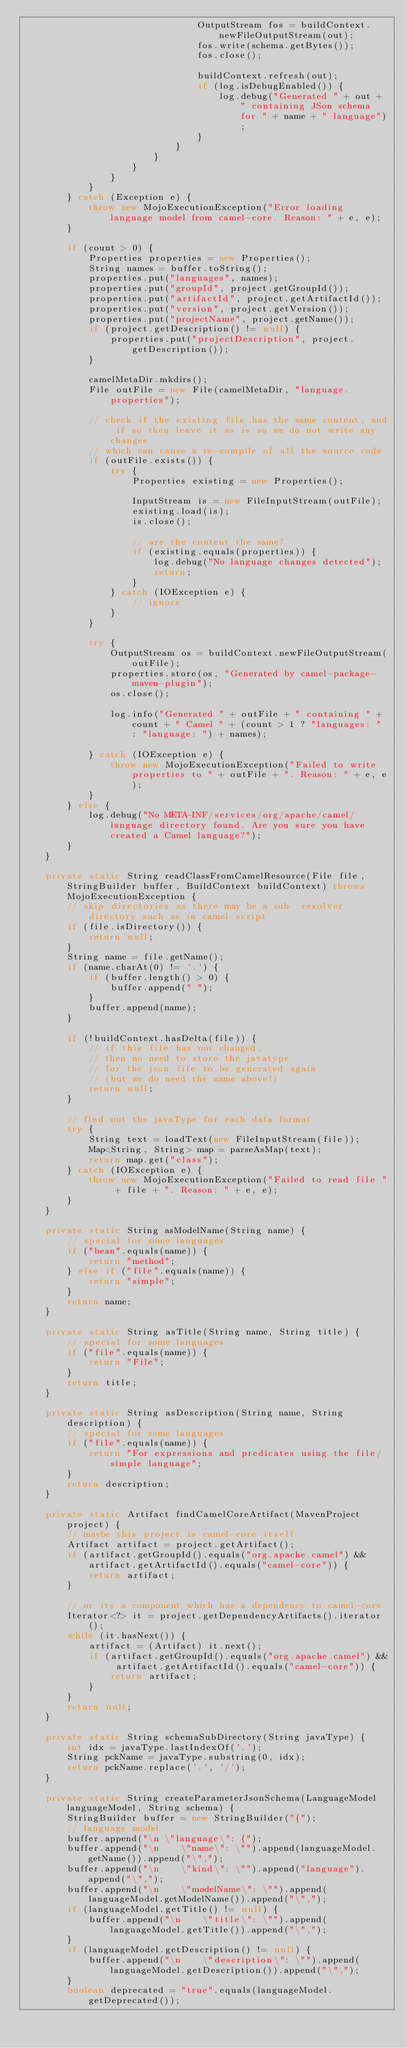Convert code to text. <code><loc_0><loc_0><loc_500><loc_500><_Java_>                                OutputStream fos = buildContext.newFileOutputStream(out);
                                fos.write(schema.getBytes());
                                fos.close();

                                buildContext.refresh(out);
                                if (log.isDebugEnabled()) {
                                    log.debug("Generated " + out + " containing JSon schema for " + name + " language");
                                }
                            }
                        }
                    }
                }
            }
        } catch (Exception e) {
            throw new MojoExecutionException("Error loading language model from camel-core. Reason: " + e, e);
        }

        if (count > 0) {
            Properties properties = new Properties();
            String names = buffer.toString();
            properties.put("languages", names);
            properties.put("groupId", project.getGroupId());
            properties.put("artifactId", project.getArtifactId());
            properties.put("version", project.getVersion());
            properties.put("projectName", project.getName());
            if (project.getDescription() != null) {
                properties.put("projectDescription", project.getDescription());
            }

            camelMetaDir.mkdirs();
            File outFile = new File(camelMetaDir, "language.properties");

            // check if the existing file has the same content, and if so then leave it as is so we do not write any changes
            // which can cause a re-compile of all the source code
            if (outFile.exists()) {
                try {
                    Properties existing = new Properties();

                    InputStream is = new FileInputStream(outFile);
                    existing.load(is);
                    is.close();

                    // are the content the same?
                    if (existing.equals(properties)) {
                        log.debug("No language changes detected");
                        return;
                    }
                } catch (IOException e) {
                    // ignore
                }
            }

            try {
                OutputStream os = buildContext.newFileOutputStream(outFile);
                properties.store(os, "Generated by camel-package-maven-plugin");
                os.close();

                log.info("Generated " + outFile + " containing " + count + " Camel " + (count > 1 ? "languages: " : "language: ") + names);

            } catch (IOException e) {
                throw new MojoExecutionException("Failed to write properties to " + outFile + ". Reason: " + e, e);
            }
        } else {
            log.debug("No META-INF/services/org/apache/camel/language directory found. Are you sure you have created a Camel language?");
        }
    }

    private static String readClassFromCamelResource(File file, StringBuilder buffer, BuildContext buildContext) throws MojoExecutionException {
        // skip directories as there may be a sub .resolver directory such as in camel-script
        if (file.isDirectory()) {
            return null;
        }
        String name = file.getName();
        if (name.charAt(0) != '.') {
            if (buffer.length() > 0) {
                buffer.append(" ");
            }
            buffer.append(name);
        }

        if (!buildContext.hasDelta(file)) {
            // if this file has not changed,
            // then no need to store the javatype
            // for the json file to be generated again
            // (but we do need the name above!)
            return null;
        }

        // find out the javaType for each data format
        try {
            String text = loadText(new FileInputStream(file));
            Map<String, String> map = parseAsMap(text);
            return map.get("class");
        } catch (IOException e) {
            throw new MojoExecutionException("Failed to read file " + file + ". Reason: " + e, e);
        }
    }

    private static String asModelName(String name) {
        // special for some languages
        if ("bean".equals(name)) {
            return "method";
        } else if ("file".equals(name)) {
            return "simple";
        }
        return name;
    }

    private static String asTitle(String name, String title) {
        // special for some languages
        if ("file".equals(name)) {
            return "File";
        }
        return title;
    }

    private static String asDescription(String name, String description) {
        // special for some languages
        if ("file".equals(name)) {
            return "For expressions and predicates using the file/simple language";
        }
        return description;
    }

    private static Artifact findCamelCoreArtifact(MavenProject project) {
        // maybe this project is camel-core itself
        Artifact artifact = project.getArtifact();
        if (artifact.getGroupId().equals("org.apache.camel") && artifact.getArtifactId().equals("camel-core")) {
            return artifact;
        }

        // or its a component which has a dependency to camel-core
        Iterator<?> it = project.getDependencyArtifacts().iterator();
        while (it.hasNext()) {
            artifact = (Artifact) it.next();
            if (artifact.getGroupId().equals("org.apache.camel") && artifact.getArtifactId().equals("camel-core")) {
                return artifact;
            }
        }
        return null;
    }

    private static String schemaSubDirectory(String javaType) {
        int idx = javaType.lastIndexOf('.');
        String pckName = javaType.substring(0, idx);
        return pckName.replace('.', '/');
    }

    private static String createParameterJsonSchema(LanguageModel languageModel, String schema) {
        StringBuilder buffer = new StringBuilder("{");
        // language model
        buffer.append("\n \"language\": {");
        buffer.append("\n    \"name\": \"").append(languageModel.getName()).append("\",");
        buffer.append("\n    \"kind\": \"").append("language").append("\",");
        buffer.append("\n    \"modelName\": \"").append(languageModel.getModelName()).append("\",");
        if (languageModel.getTitle() != null) {
            buffer.append("\n    \"title\": \"").append(languageModel.getTitle()).append("\",");
        }
        if (languageModel.getDescription() != null) {
            buffer.append("\n    \"description\": \"").append(languageModel.getDescription()).append("\",");
        }
        boolean deprecated = "true".equals(languageModel.getDeprecated());</code> 